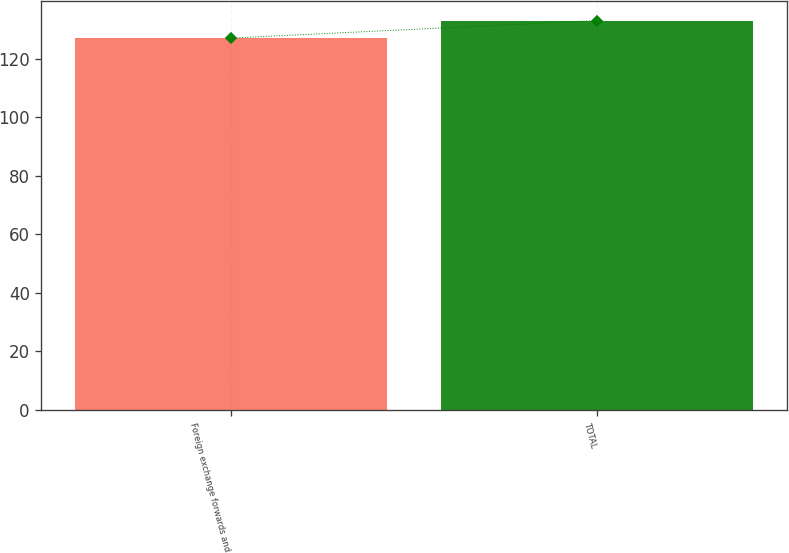<chart> <loc_0><loc_0><loc_500><loc_500><bar_chart><fcel>Foreign exchange forwards and<fcel>TOTAL<nl><fcel>127<fcel>133<nl></chart> 